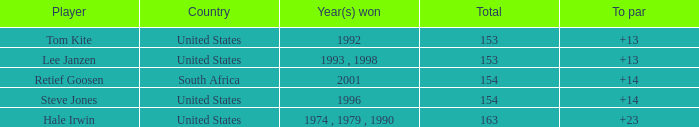What is the aggregate for south africa with a par surpassing 14? None. 